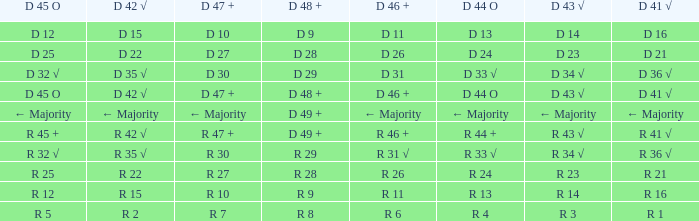What is the value of D 42 √, when the value of D 45 O is d 32 √? D 35 √. 